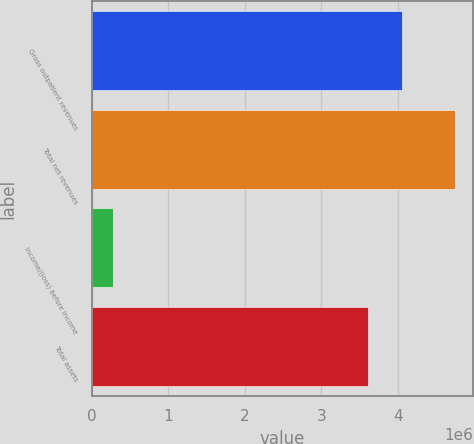<chart> <loc_0><loc_0><loc_500><loc_500><bar_chart><fcel>Gross outpatient revenues<fcel>Total net revenues<fcel>Income/(loss) before income<fcel>Total assets<nl><fcel>4.05625e+06<fcel>4.751e+06<fcel>275069<fcel>3.60866e+06<nl></chart> 